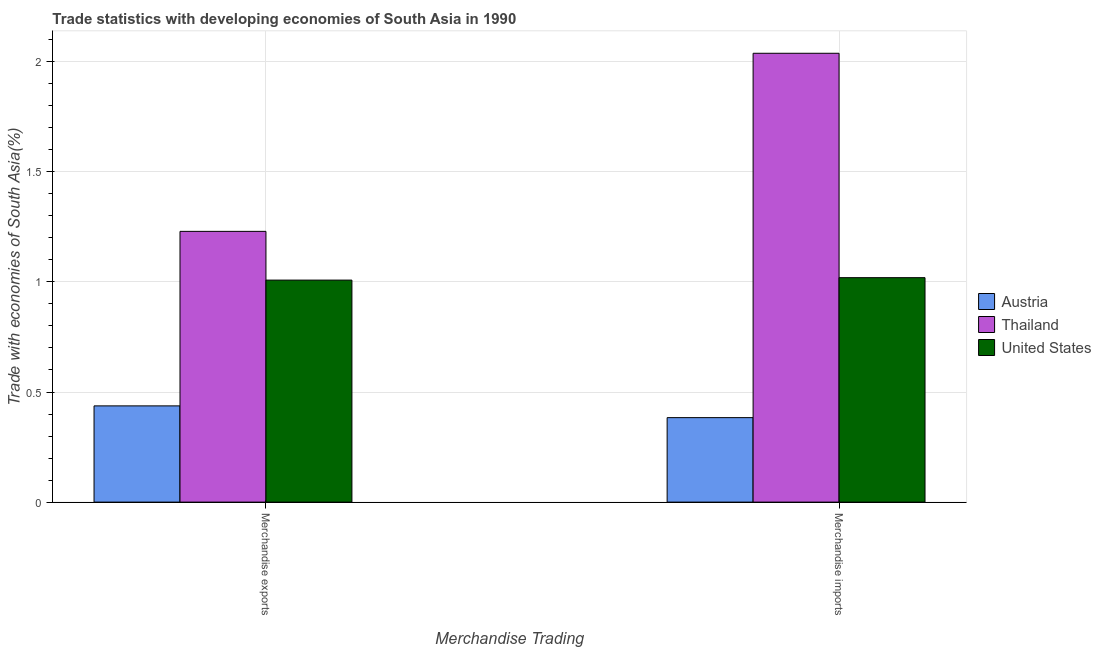How many different coloured bars are there?
Offer a very short reply. 3. Are the number of bars per tick equal to the number of legend labels?
Provide a short and direct response. Yes. How many bars are there on the 2nd tick from the left?
Provide a succinct answer. 3. What is the merchandise imports in Austria?
Make the answer very short. 0.38. Across all countries, what is the maximum merchandise exports?
Make the answer very short. 1.23. Across all countries, what is the minimum merchandise imports?
Give a very brief answer. 0.38. In which country was the merchandise exports maximum?
Offer a terse response. Thailand. In which country was the merchandise imports minimum?
Offer a terse response. Austria. What is the total merchandise imports in the graph?
Offer a terse response. 3.44. What is the difference between the merchandise imports in Austria and that in United States?
Your answer should be compact. -0.64. What is the difference between the merchandise exports in United States and the merchandise imports in Thailand?
Offer a terse response. -1.03. What is the average merchandise exports per country?
Provide a succinct answer. 0.89. What is the difference between the merchandise exports and merchandise imports in Thailand?
Your answer should be compact. -0.81. What is the ratio of the merchandise imports in United States to that in Austria?
Ensure brevity in your answer.  2.66. Is the merchandise exports in Thailand less than that in United States?
Your response must be concise. No. In how many countries, is the merchandise exports greater than the average merchandise exports taken over all countries?
Offer a very short reply. 2. What does the 2nd bar from the left in Merchandise imports represents?
Your response must be concise. Thailand. What does the 2nd bar from the right in Merchandise imports represents?
Your response must be concise. Thailand. Are all the bars in the graph horizontal?
Ensure brevity in your answer.  No. How many countries are there in the graph?
Give a very brief answer. 3. What is the difference between two consecutive major ticks on the Y-axis?
Provide a succinct answer. 0.5. Are the values on the major ticks of Y-axis written in scientific E-notation?
Provide a short and direct response. No. Does the graph contain grids?
Provide a succinct answer. Yes. Where does the legend appear in the graph?
Provide a succinct answer. Center right. How many legend labels are there?
Your answer should be very brief. 3. How are the legend labels stacked?
Your answer should be very brief. Vertical. What is the title of the graph?
Offer a terse response. Trade statistics with developing economies of South Asia in 1990. Does "Sierra Leone" appear as one of the legend labels in the graph?
Your answer should be compact. No. What is the label or title of the X-axis?
Give a very brief answer. Merchandise Trading. What is the label or title of the Y-axis?
Give a very brief answer. Trade with economies of South Asia(%). What is the Trade with economies of South Asia(%) of Austria in Merchandise exports?
Offer a very short reply. 0.44. What is the Trade with economies of South Asia(%) in Thailand in Merchandise exports?
Ensure brevity in your answer.  1.23. What is the Trade with economies of South Asia(%) of United States in Merchandise exports?
Make the answer very short. 1.01. What is the Trade with economies of South Asia(%) in Austria in Merchandise imports?
Keep it short and to the point. 0.38. What is the Trade with economies of South Asia(%) in Thailand in Merchandise imports?
Offer a very short reply. 2.04. What is the Trade with economies of South Asia(%) of United States in Merchandise imports?
Your answer should be compact. 1.02. Across all Merchandise Trading, what is the maximum Trade with economies of South Asia(%) in Austria?
Give a very brief answer. 0.44. Across all Merchandise Trading, what is the maximum Trade with economies of South Asia(%) in Thailand?
Offer a very short reply. 2.04. Across all Merchandise Trading, what is the maximum Trade with economies of South Asia(%) in United States?
Offer a very short reply. 1.02. Across all Merchandise Trading, what is the minimum Trade with economies of South Asia(%) of Austria?
Provide a succinct answer. 0.38. Across all Merchandise Trading, what is the minimum Trade with economies of South Asia(%) of Thailand?
Make the answer very short. 1.23. Across all Merchandise Trading, what is the minimum Trade with economies of South Asia(%) of United States?
Provide a short and direct response. 1.01. What is the total Trade with economies of South Asia(%) in Austria in the graph?
Your answer should be compact. 0.82. What is the total Trade with economies of South Asia(%) in Thailand in the graph?
Offer a very short reply. 3.27. What is the total Trade with economies of South Asia(%) in United States in the graph?
Make the answer very short. 2.03. What is the difference between the Trade with economies of South Asia(%) of Austria in Merchandise exports and that in Merchandise imports?
Your response must be concise. 0.05. What is the difference between the Trade with economies of South Asia(%) in Thailand in Merchandise exports and that in Merchandise imports?
Offer a very short reply. -0.81. What is the difference between the Trade with economies of South Asia(%) in United States in Merchandise exports and that in Merchandise imports?
Provide a succinct answer. -0.01. What is the difference between the Trade with economies of South Asia(%) in Austria in Merchandise exports and the Trade with economies of South Asia(%) in Thailand in Merchandise imports?
Provide a short and direct response. -1.6. What is the difference between the Trade with economies of South Asia(%) of Austria in Merchandise exports and the Trade with economies of South Asia(%) of United States in Merchandise imports?
Provide a succinct answer. -0.58. What is the difference between the Trade with economies of South Asia(%) in Thailand in Merchandise exports and the Trade with economies of South Asia(%) in United States in Merchandise imports?
Your response must be concise. 0.21. What is the average Trade with economies of South Asia(%) in Austria per Merchandise Trading?
Provide a succinct answer. 0.41. What is the average Trade with economies of South Asia(%) of Thailand per Merchandise Trading?
Make the answer very short. 1.63. What is the average Trade with economies of South Asia(%) in United States per Merchandise Trading?
Your answer should be compact. 1.01. What is the difference between the Trade with economies of South Asia(%) of Austria and Trade with economies of South Asia(%) of Thailand in Merchandise exports?
Offer a terse response. -0.79. What is the difference between the Trade with economies of South Asia(%) in Austria and Trade with economies of South Asia(%) in United States in Merchandise exports?
Provide a succinct answer. -0.57. What is the difference between the Trade with economies of South Asia(%) in Thailand and Trade with economies of South Asia(%) in United States in Merchandise exports?
Make the answer very short. 0.22. What is the difference between the Trade with economies of South Asia(%) of Austria and Trade with economies of South Asia(%) of Thailand in Merchandise imports?
Offer a very short reply. -1.65. What is the difference between the Trade with economies of South Asia(%) of Austria and Trade with economies of South Asia(%) of United States in Merchandise imports?
Your response must be concise. -0.64. What is the difference between the Trade with economies of South Asia(%) of Thailand and Trade with economies of South Asia(%) of United States in Merchandise imports?
Give a very brief answer. 1.02. What is the ratio of the Trade with economies of South Asia(%) of Austria in Merchandise exports to that in Merchandise imports?
Ensure brevity in your answer.  1.14. What is the ratio of the Trade with economies of South Asia(%) of Thailand in Merchandise exports to that in Merchandise imports?
Ensure brevity in your answer.  0.6. What is the difference between the highest and the second highest Trade with economies of South Asia(%) of Austria?
Keep it short and to the point. 0.05. What is the difference between the highest and the second highest Trade with economies of South Asia(%) in Thailand?
Ensure brevity in your answer.  0.81. What is the difference between the highest and the second highest Trade with economies of South Asia(%) in United States?
Offer a terse response. 0.01. What is the difference between the highest and the lowest Trade with economies of South Asia(%) in Austria?
Offer a terse response. 0.05. What is the difference between the highest and the lowest Trade with economies of South Asia(%) in Thailand?
Your answer should be compact. 0.81. What is the difference between the highest and the lowest Trade with economies of South Asia(%) in United States?
Offer a terse response. 0.01. 